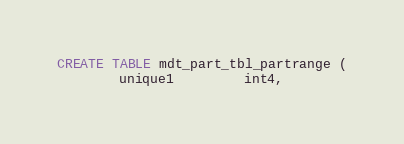Convert code to text. <code><loc_0><loc_0><loc_500><loc_500><_SQL_>CREATE TABLE mdt_part_tbl_partrange (
        unique1         int4,</code> 